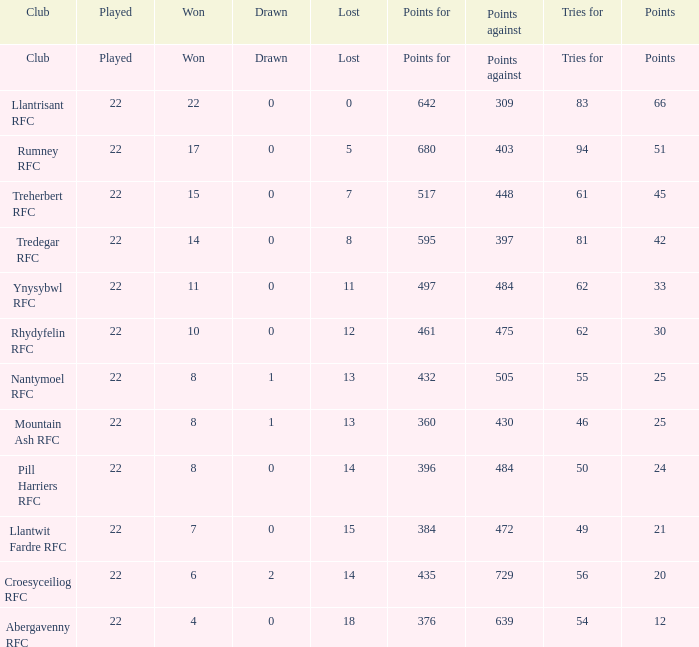How many attempts for were tallied by the team with precisely 396 points for? 50.0. 